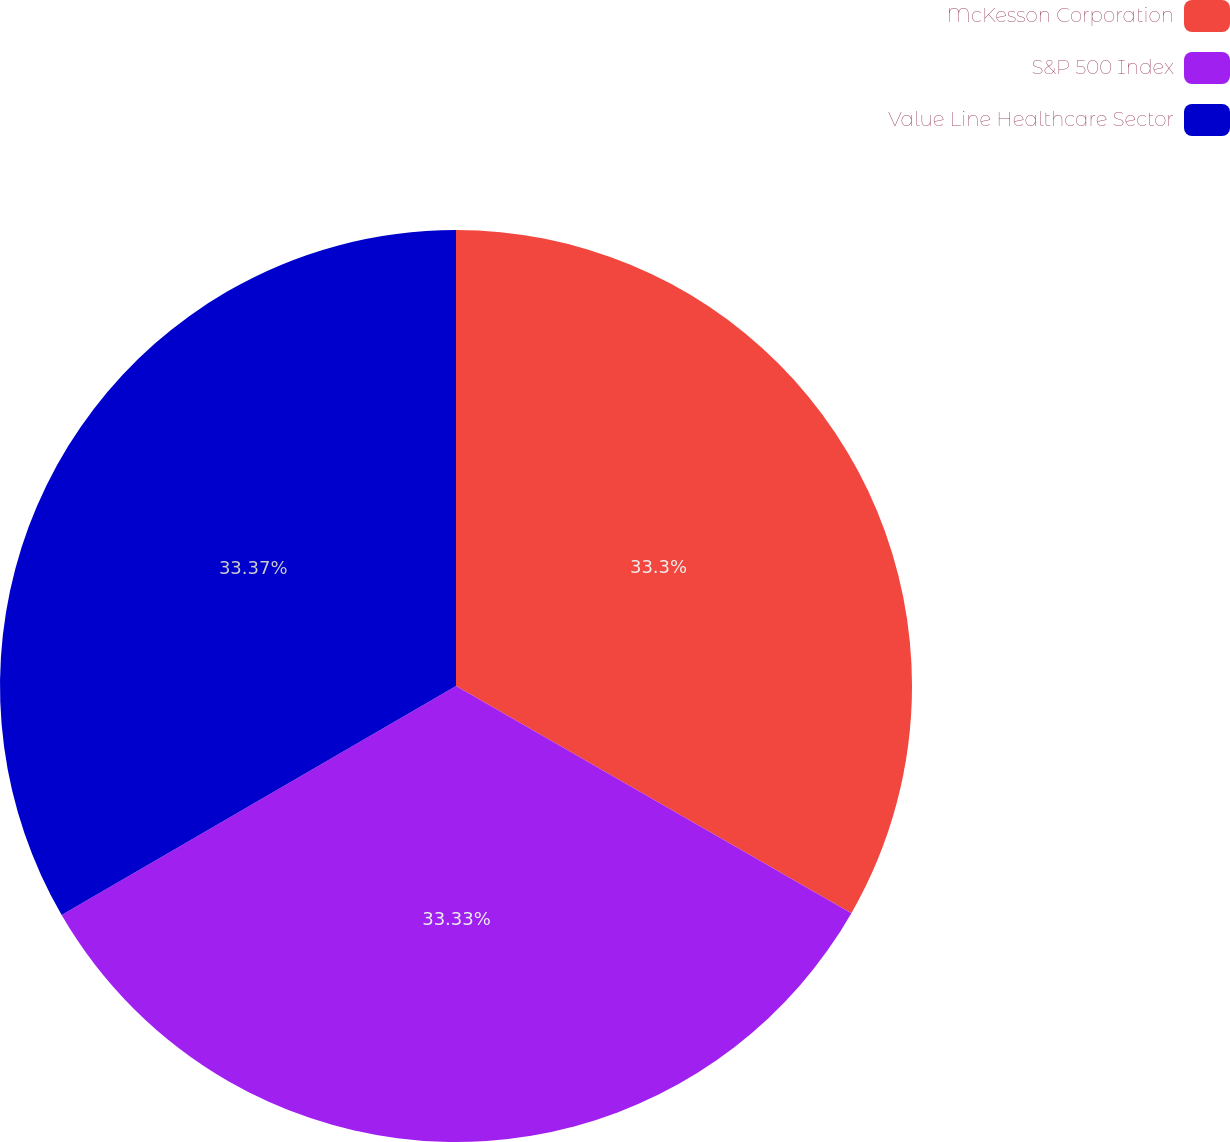Convert chart to OTSL. <chart><loc_0><loc_0><loc_500><loc_500><pie_chart><fcel>McKesson Corporation<fcel>S&P 500 Index<fcel>Value Line Healthcare Sector<nl><fcel>33.3%<fcel>33.33%<fcel>33.37%<nl></chart> 